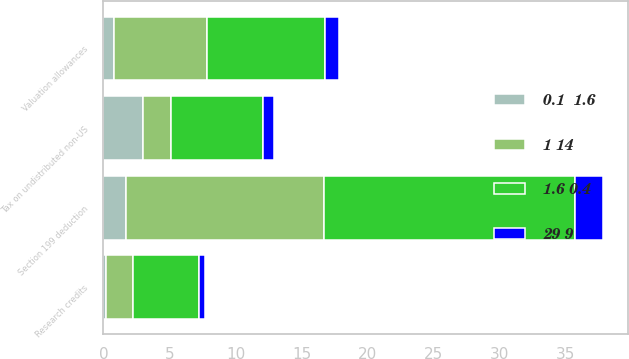Convert chart. <chart><loc_0><loc_0><loc_500><loc_500><stacked_bar_chart><ecel><fcel>Valuation allowances<fcel>Section 199 deduction<fcel>Tax on undistributed non-US<fcel>Research credits<nl><fcel>1 14<fcel>7<fcel>15<fcel>2.1<fcel>2<nl><fcel>0.1  1.6<fcel>0.8<fcel>1.7<fcel>3<fcel>0.2<nl><fcel>1.6 0.4<fcel>9<fcel>19<fcel>7<fcel>5<nl><fcel>29 9<fcel>1<fcel>2.1<fcel>0.8<fcel>0.5<nl></chart> 